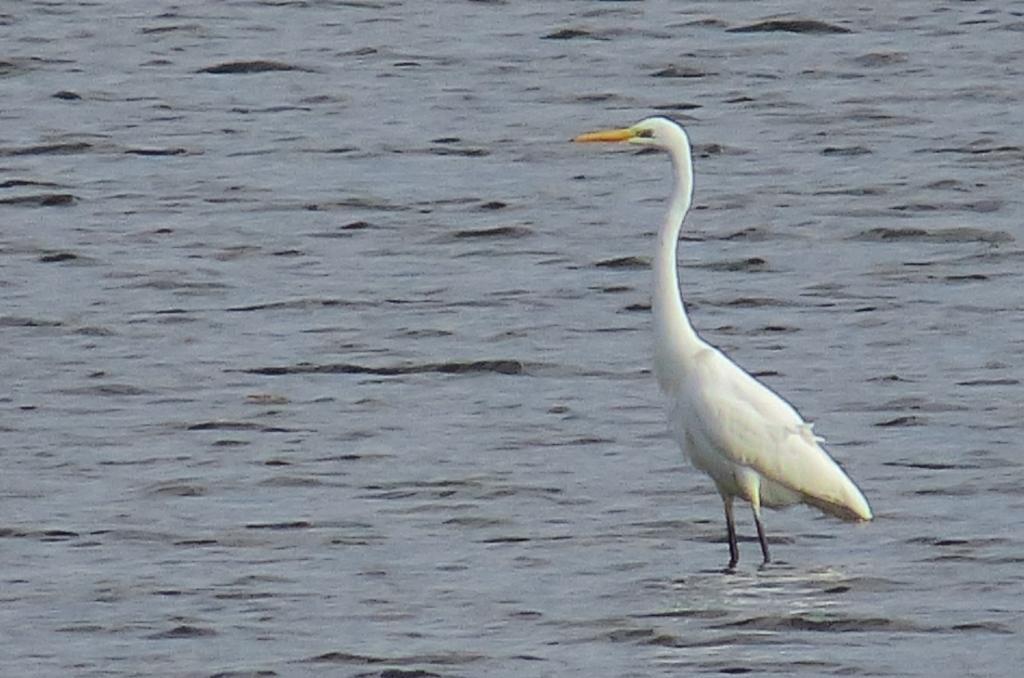Could you give a brief overview of what you see in this image? In this image there is a Great egret bird in the water. 